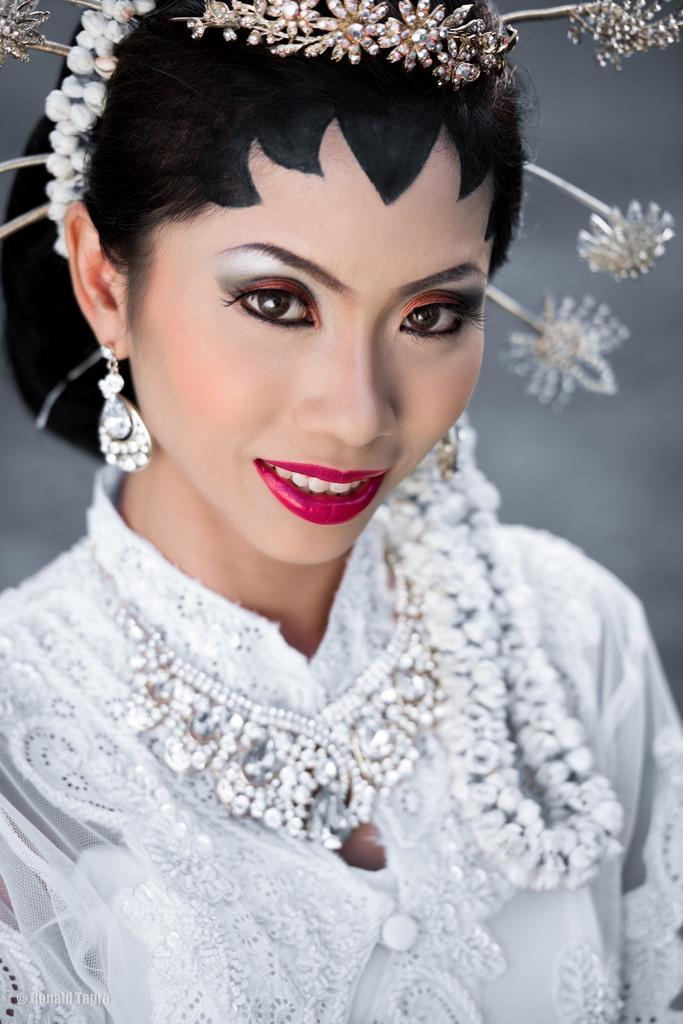Who is the main subject in the image? There is a woman in the image. What is the woman wearing? The woman is wearing a white dress. Can you describe the woman's facial features in the image? The image shows the woman's face. What type of bead is the woman holding in the image? There is no bead present in the image. What is the position of the sun in the image? The image does not show the sun, so its position cannot be determined. 